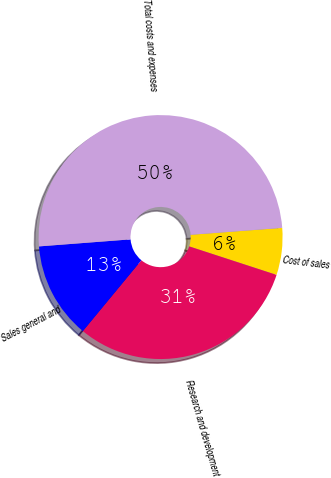Convert chart. <chart><loc_0><loc_0><loc_500><loc_500><pie_chart><fcel>Cost of sales<fcel>Research and development<fcel>Sales general and<fcel>Total costs and expenses<nl><fcel>6.22%<fcel>30.97%<fcel>12.79%<fcel>50.02%<nl></chart> 